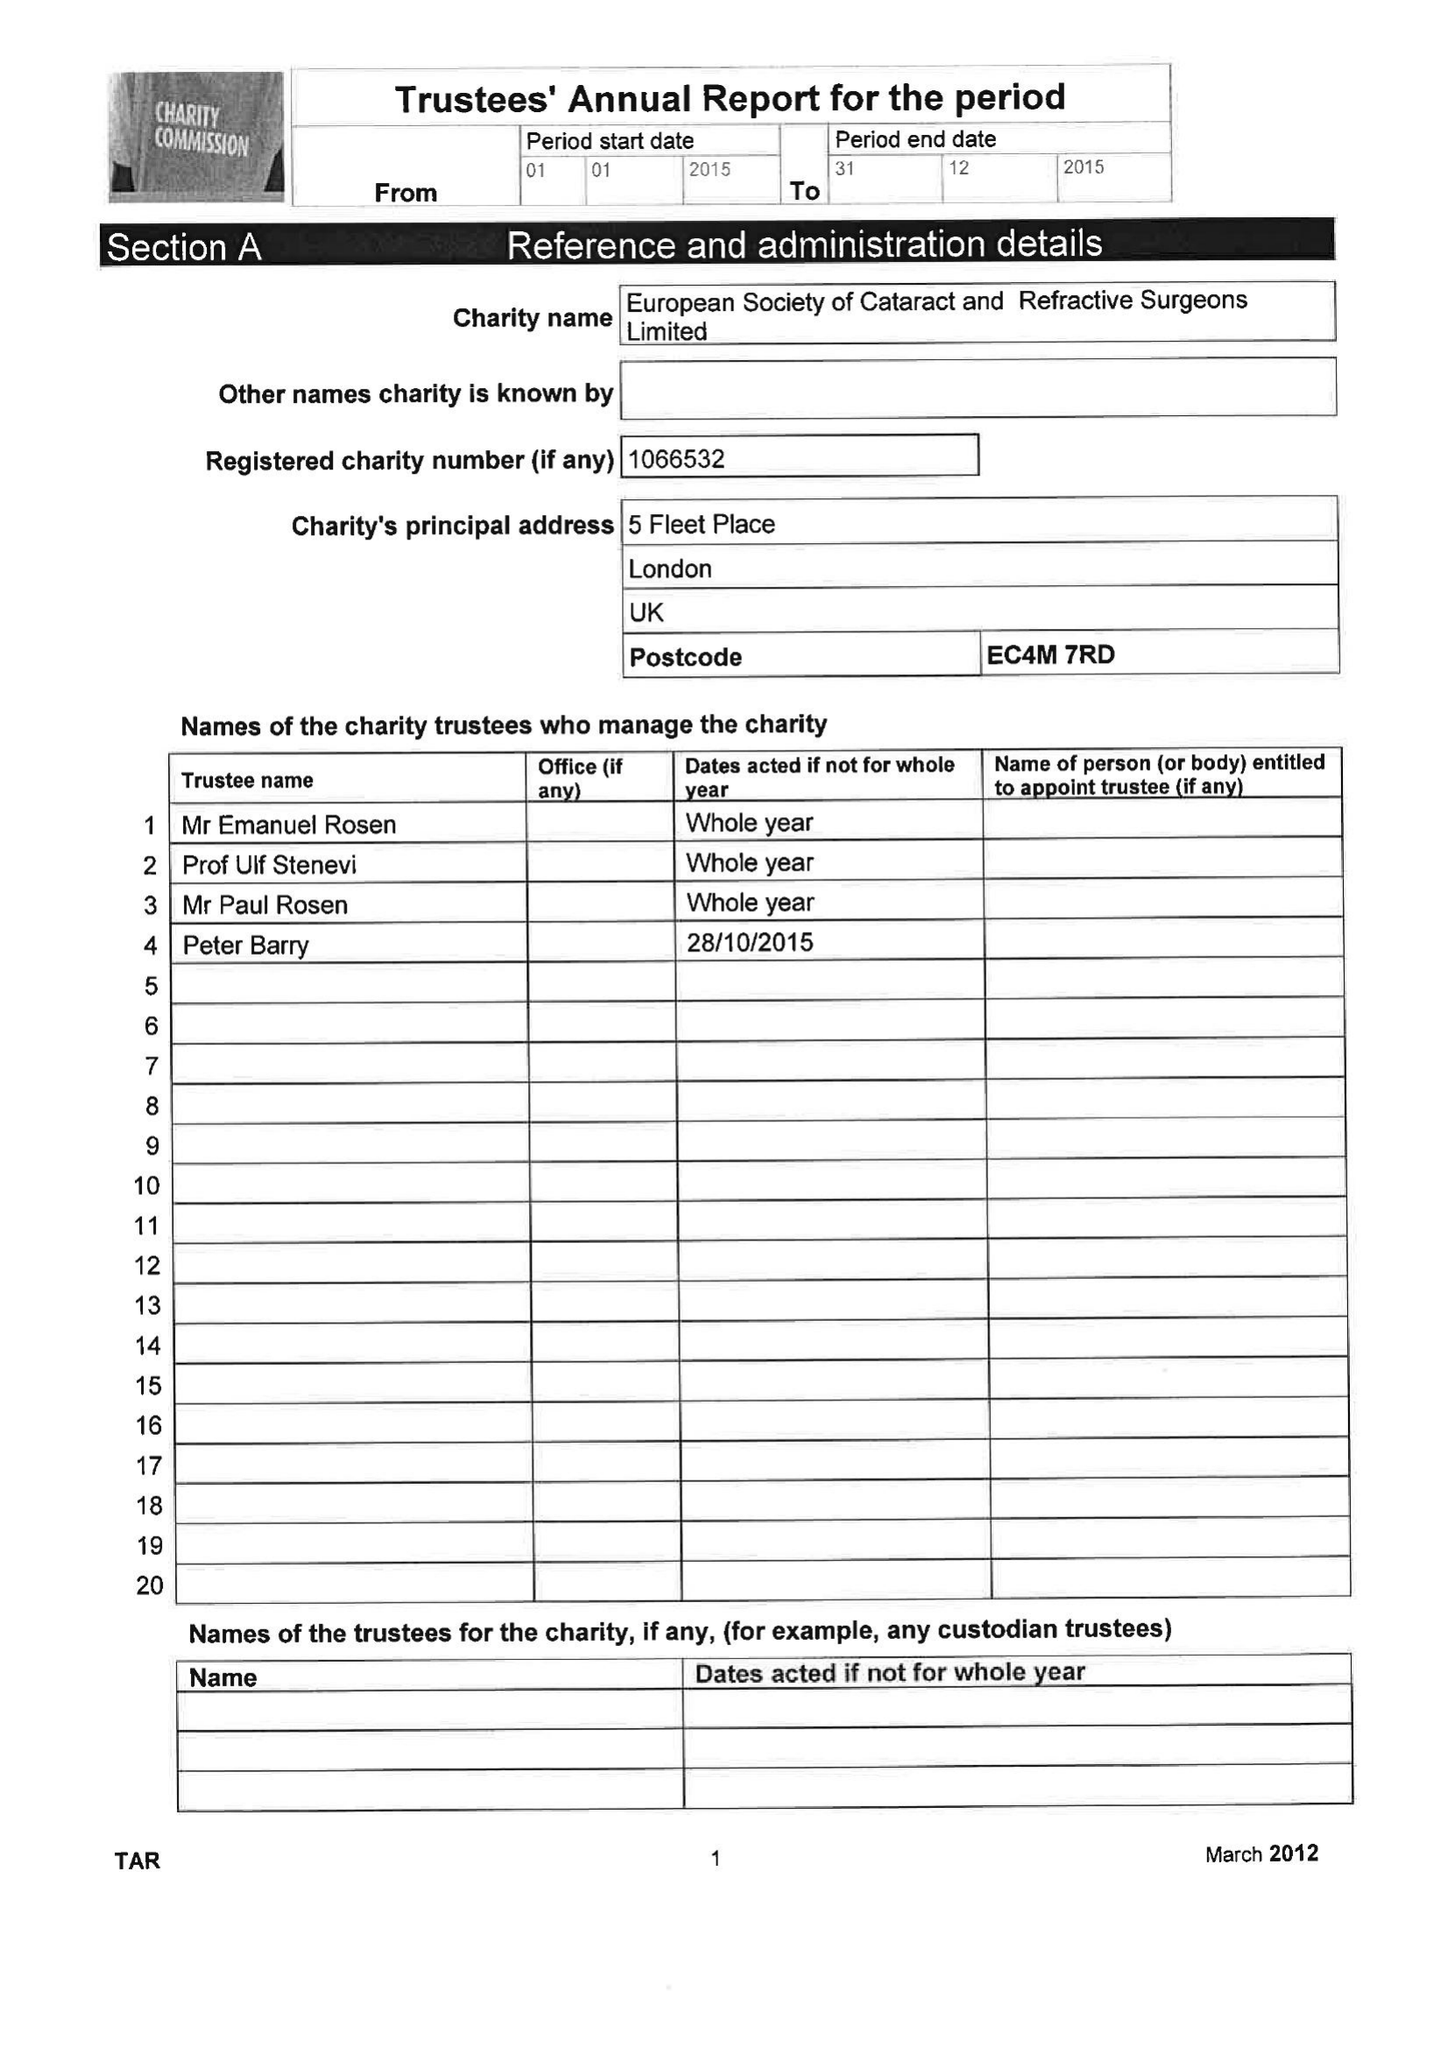What is the value for the spending_annually_in_british_pounds?
Answer the question using a single word or phrase. 1738029.00 